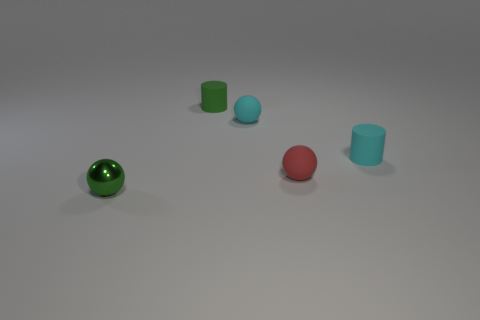Subtract all cyan spheres. How many spheres are left? 2 Add 4 big cyan matte balls. How many objects exist? 9 Subtract all cylinders. How many objects are left? 3 Add 5 green shiny objects. How many green shiny objects are left? 6 Add 3 tiny red things. How many tiny red things exist? 4 Subtract 0 brown balls. How many objects are left? 5 Subtract all red matte balls. Subtract all tiny shiny things. How many objects are left? 3 